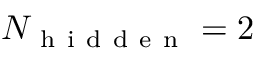Convert formula to latex. <formula><loc_0><loc_0><loc_500><loc_500>N _ { h i d d e n } = 2</formula> 